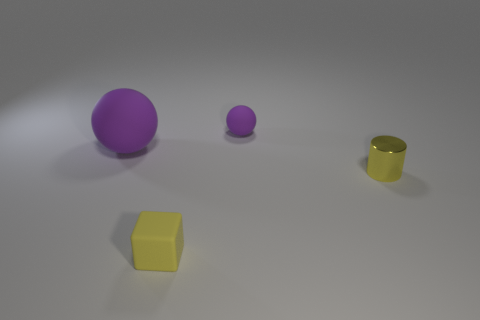What is the color of the sphere that is on the right side of the purple rubber thing that is left of the yellow matte cube? The sphere to the right of the purple object, which is itself to the left of the yellow matte cube, is small and also purple in color, matching the larger purple object beside it. 